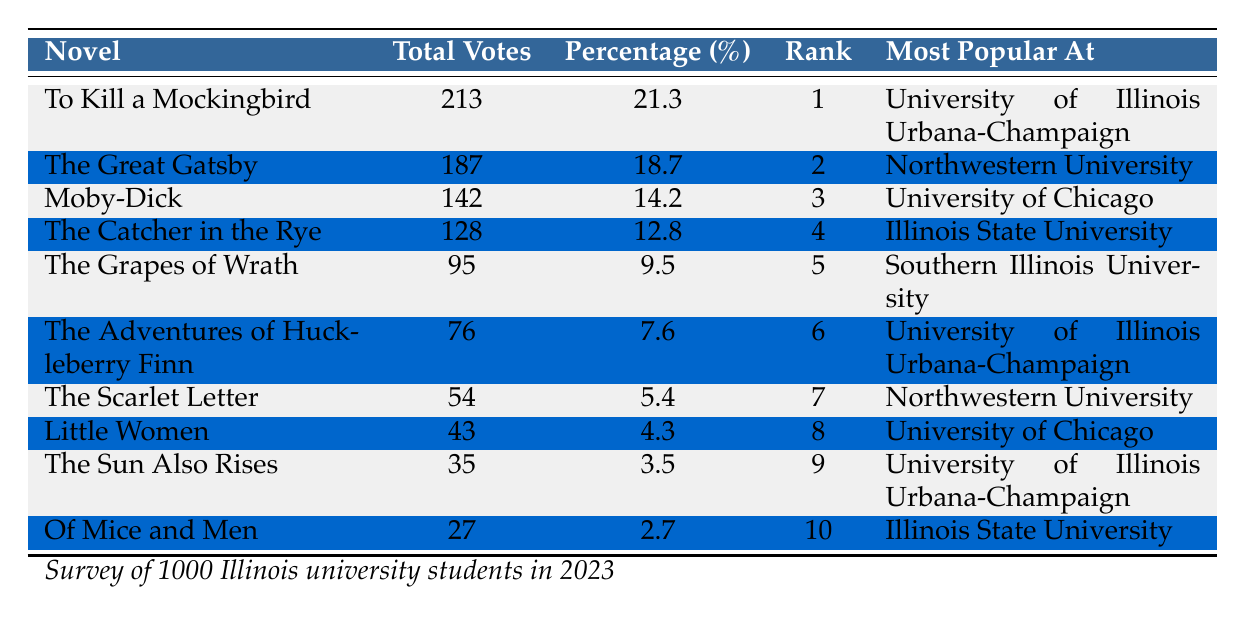What is the most popular novel among Illinois university students? The table shows that "To Kill a Mockingbird" has the highest total votes at 213, making it the most popular novel.
Answer: To Kill a Mockingbird Which university has the highest number of votes for "The Great Gatsby"? According to the table, "The Great Gatsby" received 187 votes, with it being most popular at Northwestern University.
Answer: Northwestern University What percentage of respondents voted for "Moby-Dick"? The table states that "Moby-Dick" received 142 votes, which accounts for 14.2% of the total respondents.
Answer: 14.2% Which novel received the fewest votes and how many were there? The table lists "Of Mice and Men" with a total of 27 votes, which is the least among the listed novels.
Answer: 27 If you add the votes for "Little Women" and "The Scarlet Letter", what is the total? "Little Women" has 43 votes and "The Scarlet Letter" has 54 votes. Adding them gives 43 + 54 = 97 votes in total.
Answer: 97 Is "The Adventures of Huckleberry Finn" more popular at the University of Illinois Urbana-Champaign than "The Grapes of Wrath" at Southern Illinois University? "The Adventures of Huckleberry Finn" received 76 votes at the University of Illinois Urbana-Champaign, while "The Grapes of Wrath" received 95 votes at Southern Illinois University, which makes it less popular at Illinois.
Answer: No What is the combined percentage of votes for the top two novels? The top two novels are "To Kill a Mockingbird" (21.3%) and "The Great Gatsby" (18.7%). Adding these percentages gives 21.3 + 18.7 = 40%.
Answer: 40% Which university has the most novels listed as favorites? The table indicates several novels with their respective favorite universities, with "University of Illinois Urbana-Champaign" being mentioned three times, more than any other university.
Answer: University of Illinois Urbana-Champaign Did "The Sun Also Rises" receive more or fewer votes than "Of Mice and Men"? "The Sun Also Rises" had 35 votes and "Of Mice and Men" had 27 votes, indicating that "The Sun Also Rises" received more votes.
Answer: More How many novels received less than 5% of the total votes? The novels with votes below 5% are "The Scarlet Letter" (5.4%), "Little Women" (4.3%), "The Sun Also Rises" (3.5%), and "Of Mice and Men" (2.7%). Counting them, there are four novels that received less than 5% of the votes.
Answer: 4 